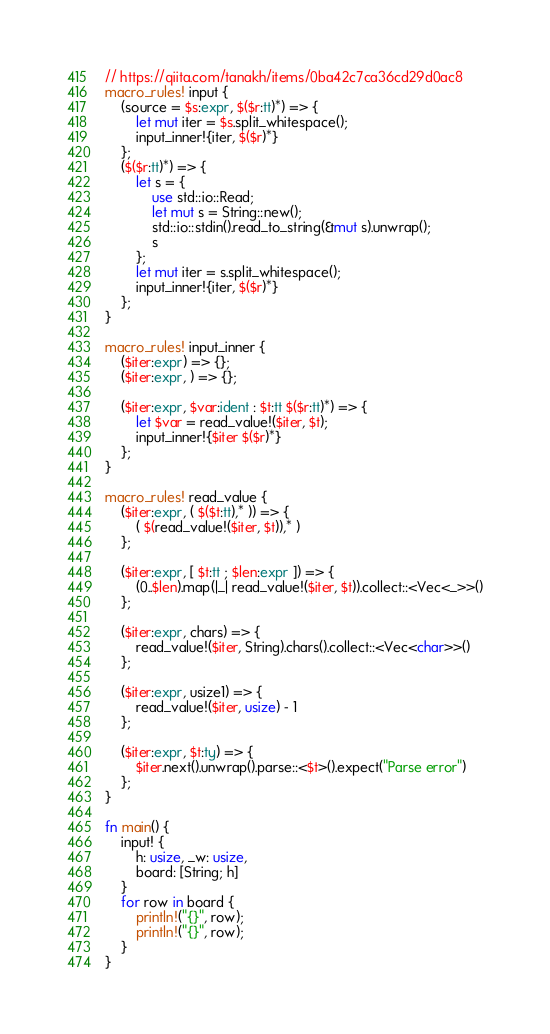<code> <loc_0><loc_0><loc_500><loc_500><_Rust_>// https://qiita.com/tanakh/items/0ba42c7ca36cd29d0ac8
macro_rules! input {
    (source = $s:expr, $($r:tt)*) => {
        let mut iter = $s.split_whitespace();
        input_inner!{iter, $($r)*}
    };
    ($($r:tt)*) => {
        let s = {
            use std::io::Read;
            let mut s = String::new();
            std::io::stdin().read_to_string(&mut s).unwrap();
            s
        };
        let mut iter = s.split_whitespace();
        input_inner!{iter, $($r)*}
    };
}

macro_rules! input_inner {
    ($iter:expr) => {};
    ($iter:expr, ) => {};

    ($iter:expr, $var:ident : $t:tt $($r:tt)*) => {
        let $var = read_value!($iter, $t);
        input_inner!{$iter $($r)*}
    };
}

macro_rules! read_value {
    ($iter:expr, ( $($t:tt),* )) => {
        ( $(read_value!($iter, $t)),* )
    };

    ($iter:expr, [ $t:tt ; $len:expr ]) => {
        (0..$len).map(|_| read_value!($iter, $t)).collect::<Vec<_>>()
    };

    ($iter:expr, chars) => {
        read_value!($iter, String).chars().collect::<Vec<char>>()
    };

    ($iter:expr, usize1) => {
        read_value!($iter, usize) - 1
    };

    ($iter:expr, $t:ty) => {
        $iter.next().unwrap().parse::<$t>().expect("Parse error")
    };
}

fn main() {
    input! {
        h: usize, _w: usize,
        board: [String; h]
    }
    for row in board {
        println!("{}", row);
        println!("{}", row);
    }
}
</code> 